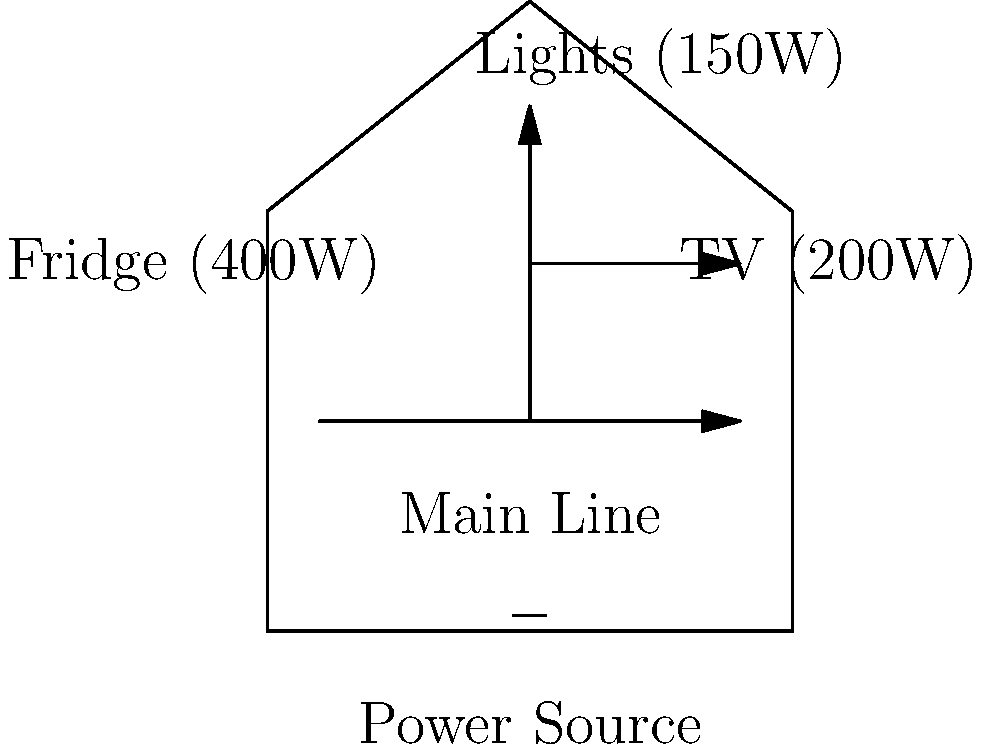In your Austin Peay dorm room, you've set up a simplified electrical system similar to the diagram. If you run all appliances simultaneously for 5 hours, how much energy is consumed in kilowatt-hours (kWh)? Assume the system operates at 120V and calculate the total current draw. Let's approach this step-by-step:

1) First, we need to calculate the total power consumption:
   TV: 200W
   Lights: 150W
   Fridge: 400W
   Total Power = 200W + 150W + 400W = 750W

2) Convert watts to kilowatts:
   750W = 0.75kW

3) Calculate energy consumption:
   Energy (kWh) = Power (kW) × Time (hours)
   Energy = 0.75kW × 5 hours = 3.75kWh

4) To calculate the total current draw:
   Using the formula P = VI, where
   P = Power (W)
   V = Voltage (V)
   I = Current (A)

   750W = 120V × I
   I = 750W ÷ 120V = 6.25A

Therefore, the energy consumed is 3.75kWh, and the total current draw is 6.25A.
Answer: 3.75kWh; 6.25A 